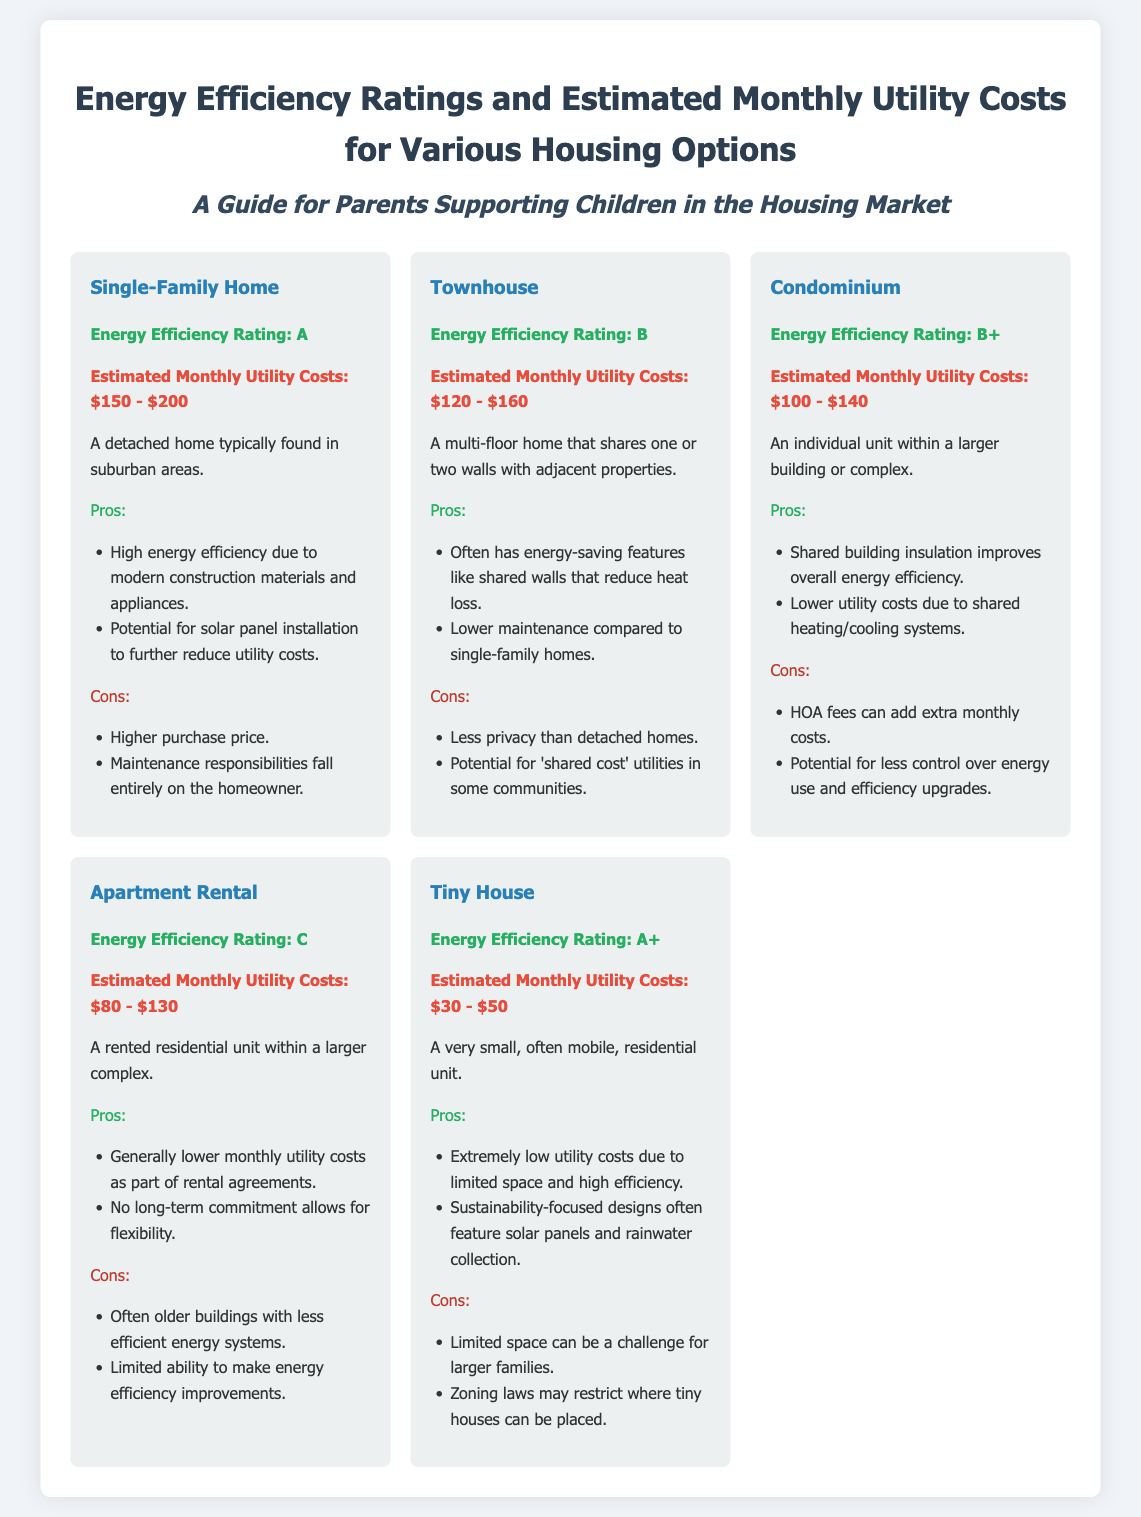What is the energy efficiency rating of a Single-Family Home? The energy efficiency rating for a Single-Family Home is listed directly in the document.
Answer: A What are the estimated monthly utility costs for a Tiny House? The estimated monthly utility costs for a Tiny House are provided in the housing option description.
Answer: $30 - $50 What is one advantage of living in a Townhouse? The document outlines pros and cons for each housing option; one pro for Townhouses is provided there.
Answer: Energy-saving features What is the energy efficiency rating of the Apartment Rental? The document specifies the energy efficiency rating for the Apartment Rental option.
Answer: C What is a con of living in a Condominium? This information is found under the cons section for the Condominium, which lists challenges of living there.
Answer: HOA fees Which housing option has the highest energy efficiency rating? The question can be answered by comparing the ratings provided for each option in the document.
Answer: Tiny House How does the energy efficiency rating for a Condominium compare to that of a Townhouse? This requires evaluating the ratings given in the document for both options.
Answer: B+ What type of housing typically has higher purchase prices? The document mentions characteristics for different housing options, including cost implications for one type.
Answer: Single-Family Home 